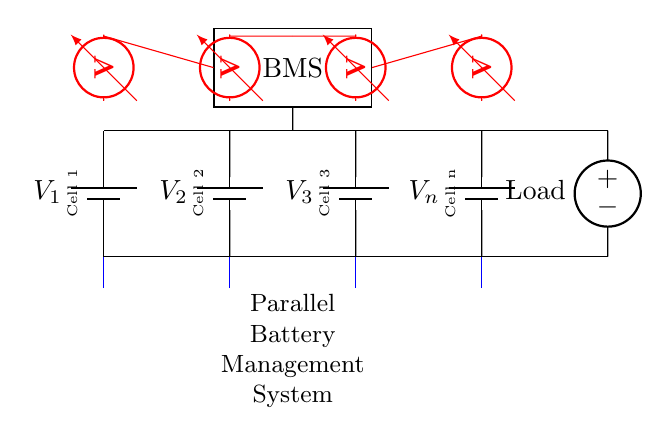What kind of circuit is shown here? The circuit is a parallel circuit because all battery cells are connected across the same voltage nodes, providing multiple paths for current.
Answer: Parallel circuit How many battery cells are present in this diagram? There are four battery cells indicated by the labels V1, V2, V3, and Vn in the diagram.
Answer: Four battery cells What is the role of the BMS in the circuit? The BMS, or Battery Management System, monitors the voltage and temperature of each cell, ensuring safe and efficient operation of the battery pack.
Answer: Monitor What type of sensors are used in this circuit? Thermistors are used as temperature sensors to measure the temperature of each battery cell, indicated by the blue symbols connected at the bottom of each cell.
Answer: Thermistors What will happen to the overall voltage of the circuit? The overall voltage of a parallel circuit remains the same as the individual battery cells' voltage, as they are all connected across the same nodes.
Answer: Same as one cell's voltage Can you explain how load is supported in this circuit? The load receives current from multiple parallel paths, allowing for shared power delivery and higher overall current capacity without increasing the voltage.
Answer: Shared power delivery 